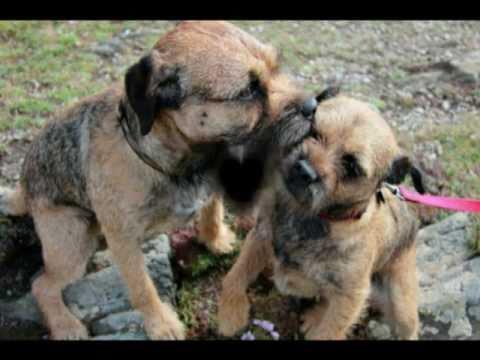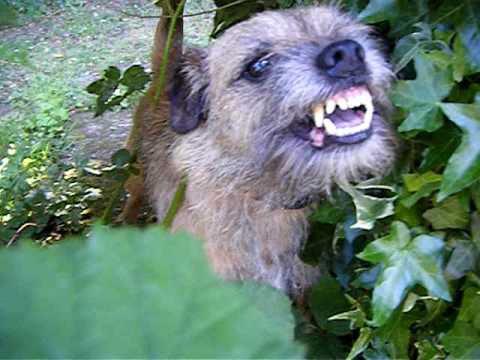The first image is the image on the left, the second image is the image on the right. Analyze the images presented: Is the assertion "There are exactly two puppies, one in each image, and both of their faces are visible." valid? Answer yes or no. No. The first image is the image on the left, the second image is the image on the right. Analyze the images presented: Is the assertion "The left and right image contains the same number of dogs with at least one sitting." valid? Answer yes or no. No. 